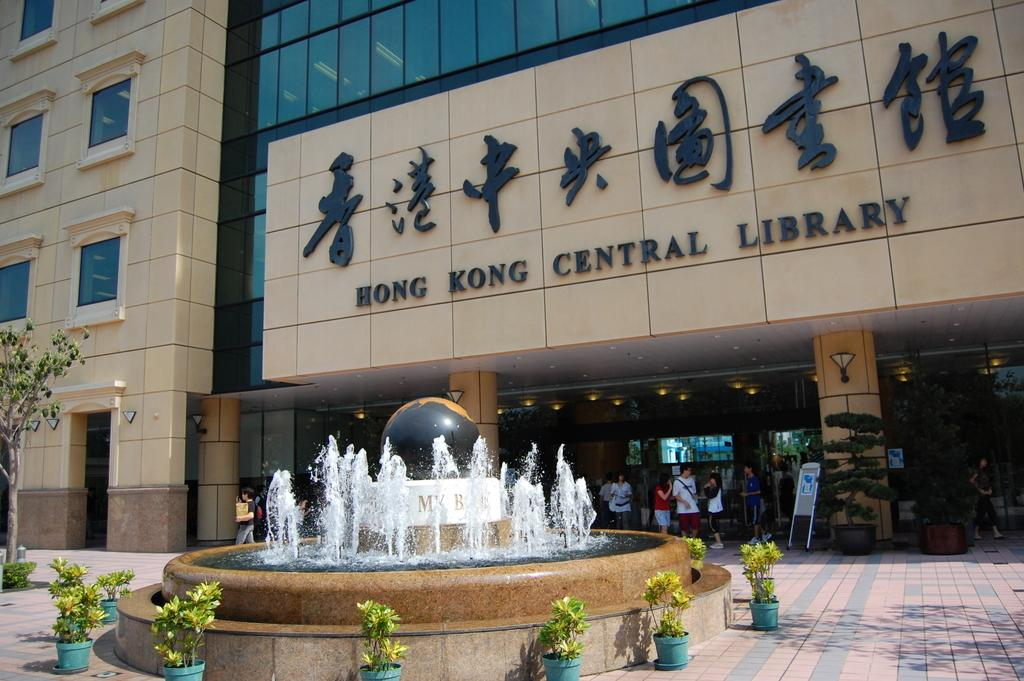<image>
Create a compact narrative representing the image presented. The Honk Kong Central Library has people standing underneath it's entrance. 